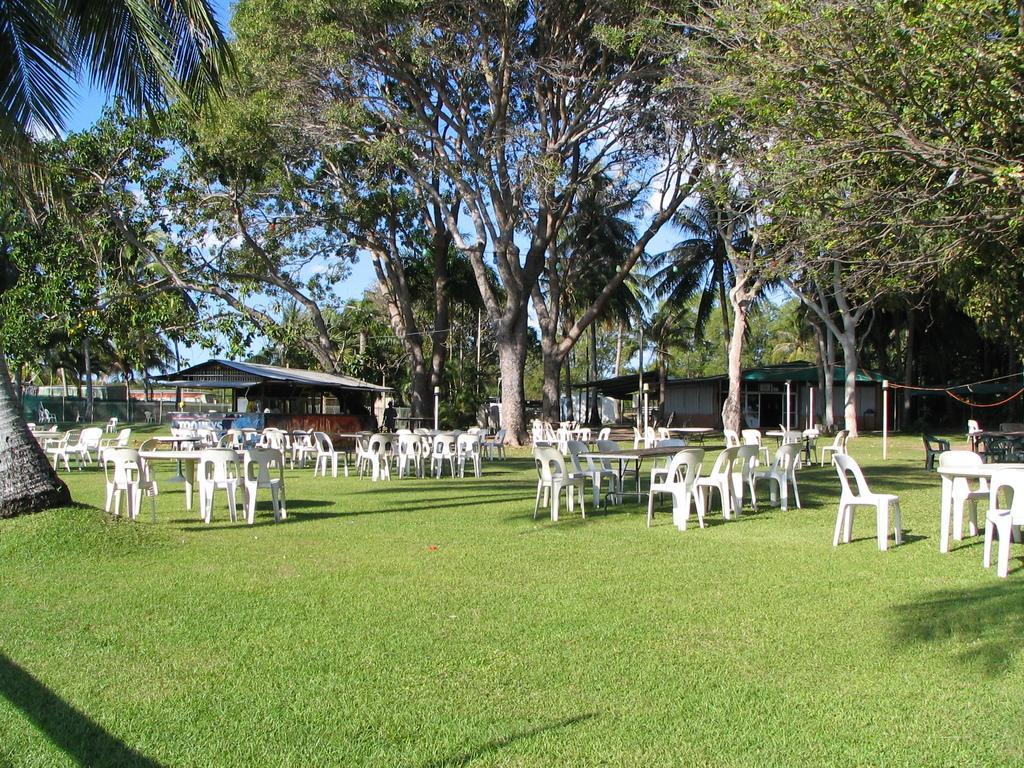Can you describe this image briefly? In this image I can see tables and white chairs on the grass. There are trees and shacks at the back. 